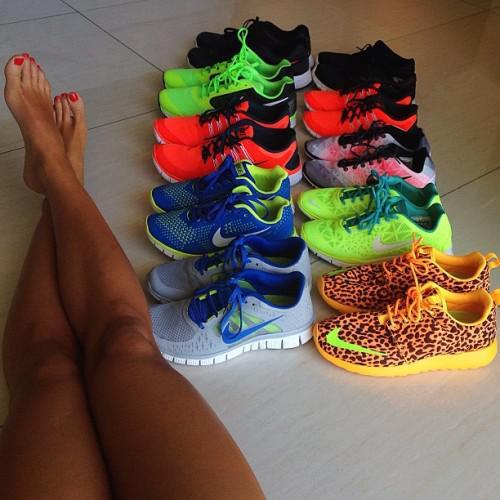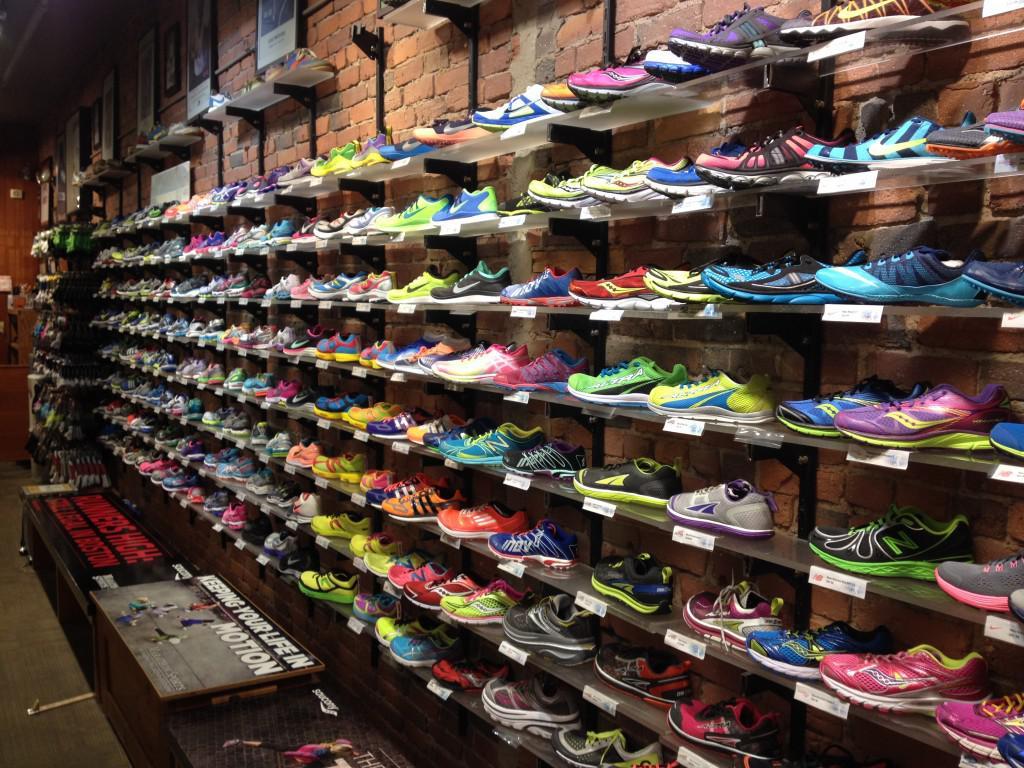The first image is the image on the left, the second image is the image on the right. Examine the images to the left and right. Is the description "The left image shows many shoes arranged in rows on shelves." accurate? Answer yes or no. No. The first image is the image on the left, the second image is the image on the right. Examine the images to the left and right. Is the description "One image shows several pairs of shoes lined up neatly on the floor." accurate? Answer yes or no. Yes. 